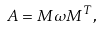<formula> <loc_0><loc_0><loc_500><loc_500>A = M \omega M ^ { T } ,</formula> 